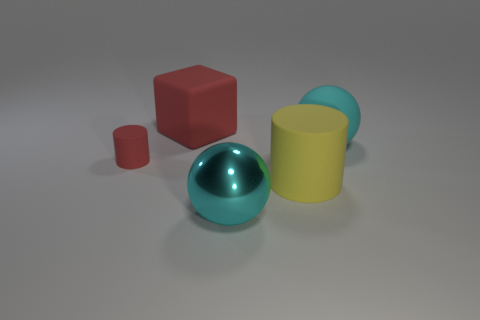Add 5 big rubber things. How many objects exist? 10 Subtract all cubes. How many objects are left? 4 Subtract all red things. Subtract all spheres. How many objects are left? 1 Add 5 large red blocks. How many large red blocks are left? 6 Add 3 tiny yellow shiny spheres. How many tiny yellow shiny spheres exist? 3 Subtract 0 brown cylinders. How many objects are left? 5 